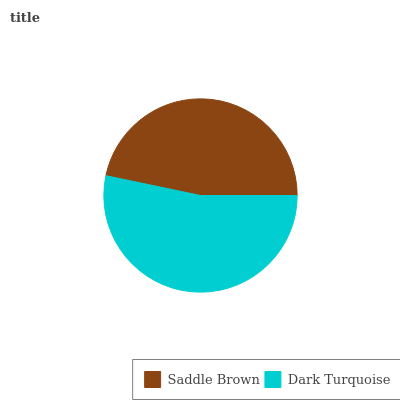Is Saddle Brown the minimum?
Answer yes or no. Yes. Is Dark Turquoise the maximum?
Answer yes or no. Yes. Is Dark Turquoise the minimum?
Answer yes or no. No. Is Dark Turquoise greater than Saddle Brown?
Answer yes or no. Yes. Is Saddle Brown less than Dark Turquoise?
Answer yes or no. Yes. Is Saddle Brown greater than Dark Turquoise?
Answer yes or no. No. Is Dark Turquoise less than Saddle Brown?
Answer yes or no. No. Is Dark Turquoise the high median?
Answer yes or no. Yes. Is Saddle Brown the low median?
Answer yes or no. Yes. Is Saddle Brown the high median?
Answer yes or no. No. Is Dark Turquoise the low median?
Answer yes or no. No. 